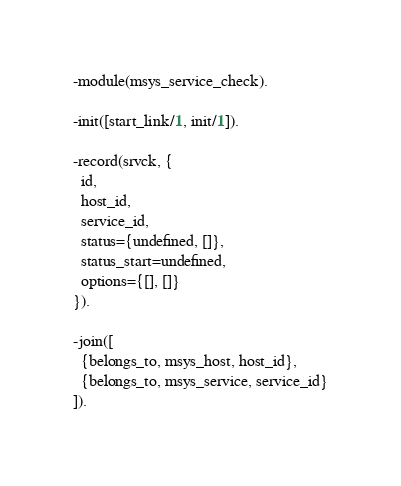Convert code to text. <code><loc_0><loc_0><loc_500><loc_500><_Erlang_>-module(msys_service_check).

-init([start_link/1, init/1]).

-record(srvck, {
  id,
  host_id,
  service_id,
  status={undefined, []},
  status_start=undefined,
  options={[], []}
}).

-join([
  {belongs_to, msys_host, host_id},
  {belongs_to, msys_service, service_id}
]).
</code> 